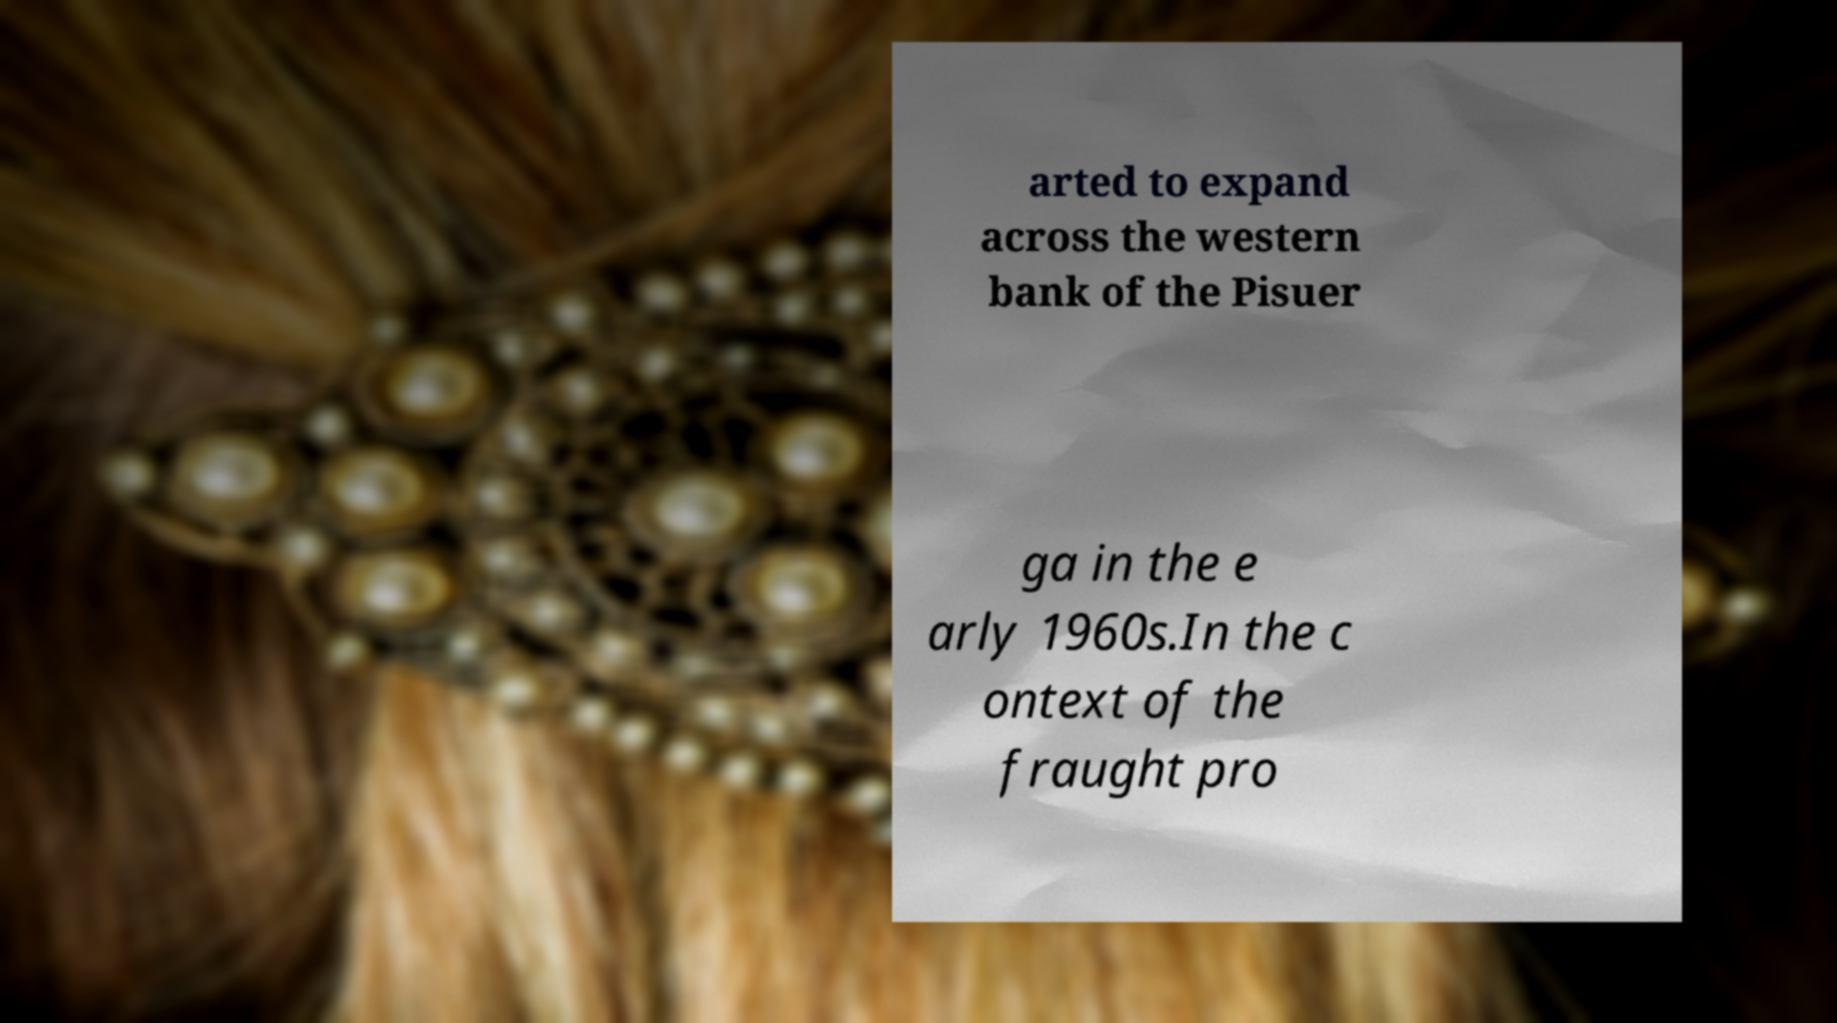Could you extract and type out the text from this image? arted to expand across the western bank of the Pisuer ga in the e arly 1960s.In the c ontext of the fraught pro 